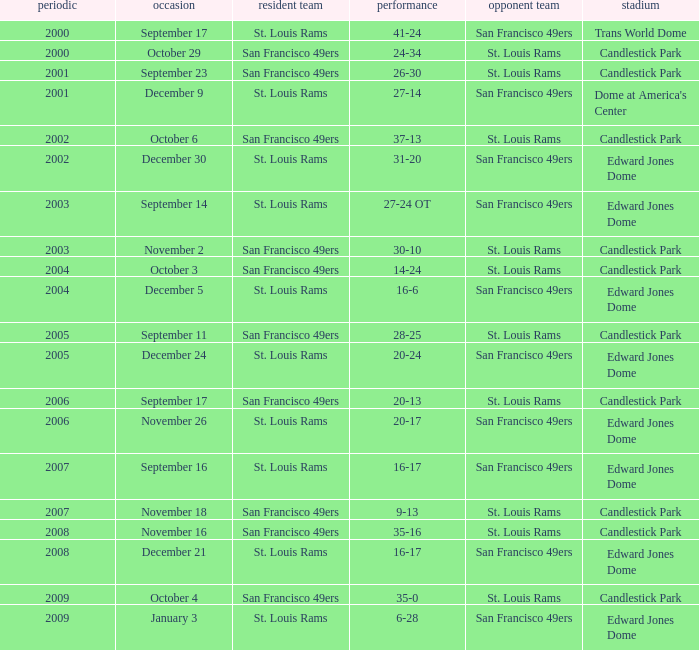What was the Venue of the San Francisco 49ers Home game with a Result of 30-10? Candlestick Park. 